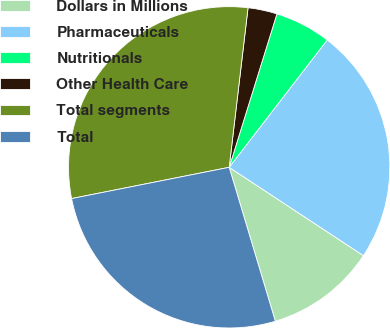Convert chart. <chart><loc_0><loc_0><loc_500><loc_500><pie_chart><fcel>Dollars in Millions<fcel>Pharmaceuticals<fcel>Nutritionals<fcel>Other Health Care<fcel>Total segments<fcel>Total<nl><fcel>11.1%<fcel>23.82%<fcel>5.64%<fcel>2.93%<fcel>29.99%<fcel>26.52%<nl></chart> 